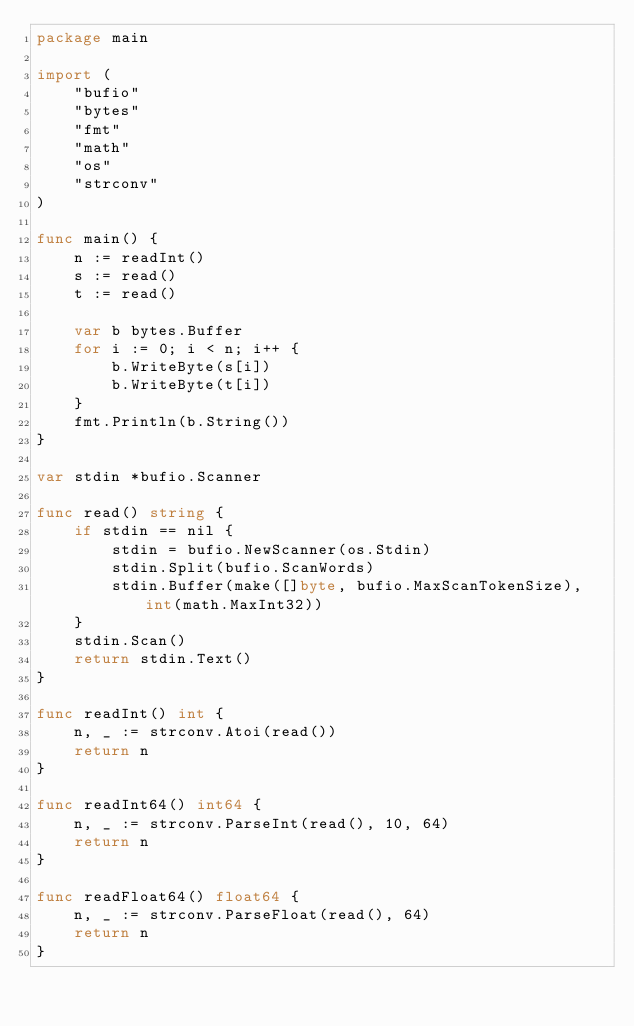Convert code to text. <code><loc_0><loc_0><loc_500><loc_500><_Go_>package main

import (
	"bufio"
	"bytes"
	"fmt"
	"math"
	"os"
	"strconv"
)

func main() {
	n := readInt()
	s := read()
	t := read()

	var b bytes.Buffer
	for i := 0; i < n; i++ {
		b.WriteByte(s[i])
		b.WriteByte(t[i])
	}
	fmt.Println(b.String())
}

var stdin *bufio.Scanner

func read() string {
	if stdin == nil {
		stdin = bufio.NewScanner(os.Stdin)
		stdin.Split(bufio.ScanWords)
		stdin.Buffer(make([]byte, bufio.MaxScanTokenSize), int(math.MaxInt32))
	}
	stdin.Scan()
	return stdin.Text()
}

func readInt() int {
	n, _ := strconv.Atoi(read())
	return n
}

func readInt64() int64 {
	n, _ := strconv.ParseInt(read(), 10, 64)
	return n
}

func readFloat64() float64 {
	n, _ := strconv.ParseFloat(read(), 64)
	return n
}
</code> 